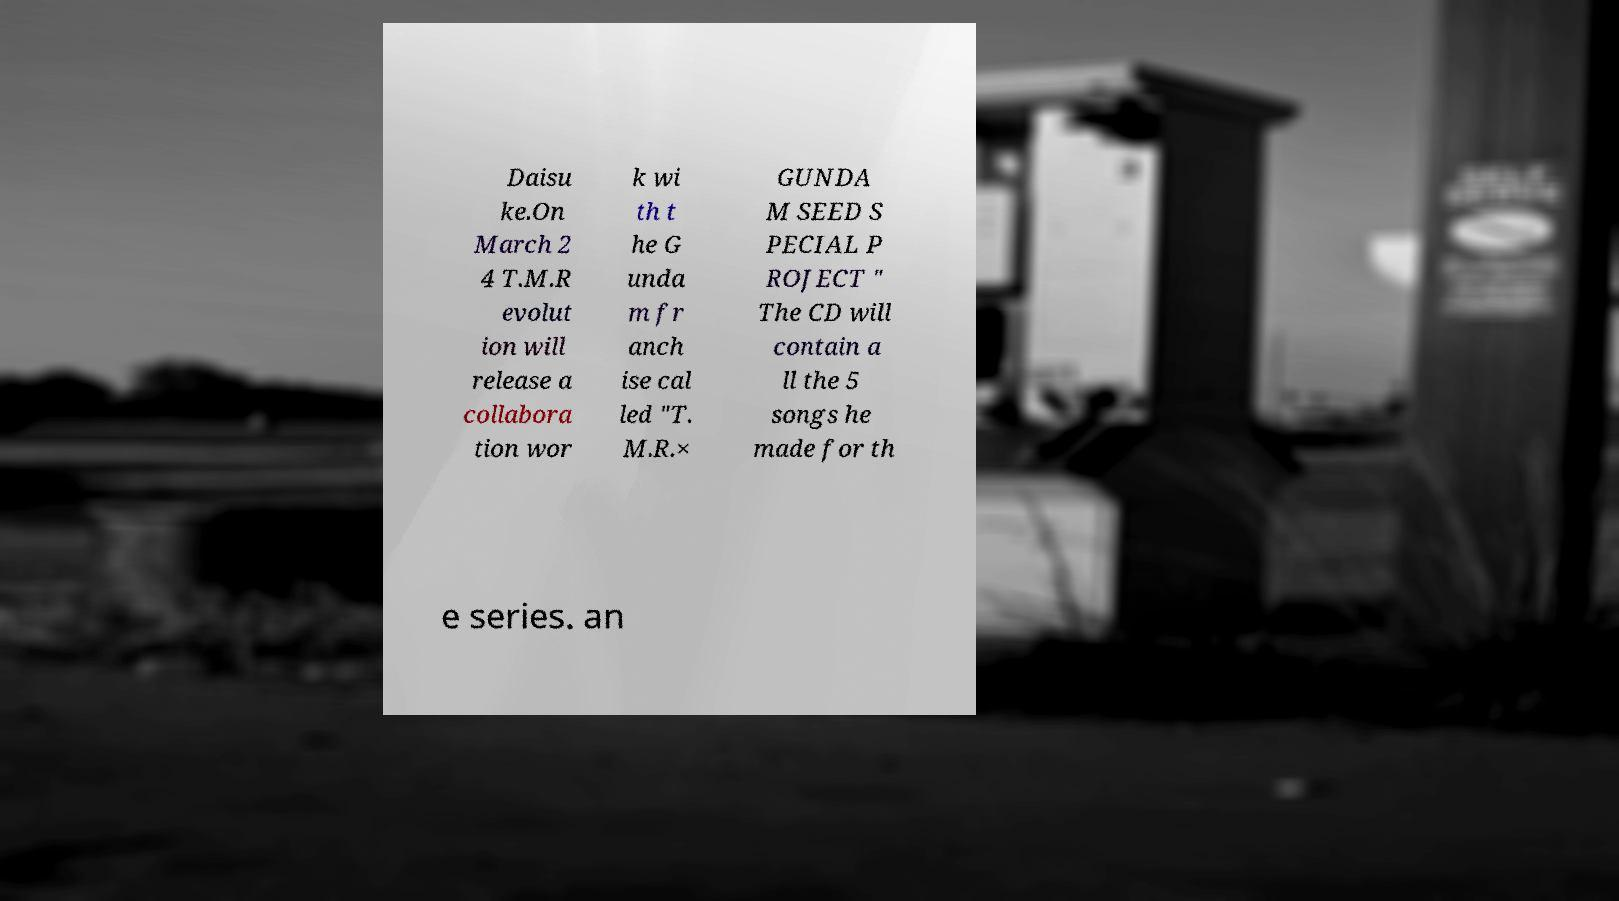Could you assist in decoding the text presented in this image and type it out clearly? Daisu ke.On March 2 4 T.M.R evolut ion will release a collabora tion wor k wi th t he G unda m fr anch ise cal led "T. M.R.× GUNDA M SEED S PECIAL P ROJECT " The CD will contain a ll the 5 songs he made for th e series. an 